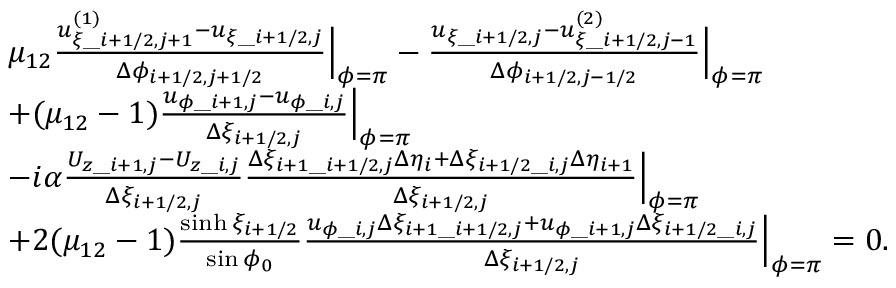<formula> <loc_0><loc_0><loc_500><loc_500>\begin{array} { r l } & { \begin{array} { r l } & { \mu _ { 1 2 } \frac { u _ { \xi \_ i + 1 / 2 , j + 1 } ^ { ( 1 ) } - u _ { \xi \_ i + 1 / 2 , j } } { \Delta \phi _ { i + 1 / 2 , j + 1 / 2 } } \Big | _ { \phi = \pi } - \frac { u _ { \xi \_ i + 1 / 2 , j } - u _ { \xi \_ i + 1 / 2 , j - 1 } ^ { ( 2 ) } } { \Delta \phi _ { i + 1 / 2 , j - 1 / 2 } } \Big | _ { \phi = \pi } } \\ & { + ( \mu _ { 1 2 } - 1 ) \frac { u _ { \phi \_ i + 1 , j } - u _ { \phi \_ i , j } } { \Delta \xi _ { i + 1 / 2 , j } } \Big | _ { \phi = \pi } } \\ & { - i \alpha \frac { U _ { z \_ i + 1 , j } - U _ { z \_ i , j } } { \Delta \xi _ { i + 1 / 2 , j } } \frac { \Delta \xi _ { i + 1 \_ i + 1 / 2 , j } \Delta \eta _ { i } + \Delta \xi _ { i + 1 / 2 \_ i , j } \Delta \eta _ { i + 1 } } { \Delta \xi _ { i + 1 / 2 , j } } \Big | _ { \phi = \pi } } \\ & { + 2 ( \mu _ { 1 2 } - 1 ) \frac { \sinh \xi _ { i + 1 / 2 } } { \sin \phi _ { 0 } } \frac { u _ { \phi \_ i , j } \Delta \xi _ { i + 1 \_ i + 1 / 2 , j } + u _ { \phi \_ i + 1 , j } \Delta \xi _ { i + 1 / 2 \_ i , j } } { \Delta \xi _ { i + 1 / 2 , j } } \Big | _ { \phi = \pi } = 0 . } \end{array} } \end{array}</formula> 